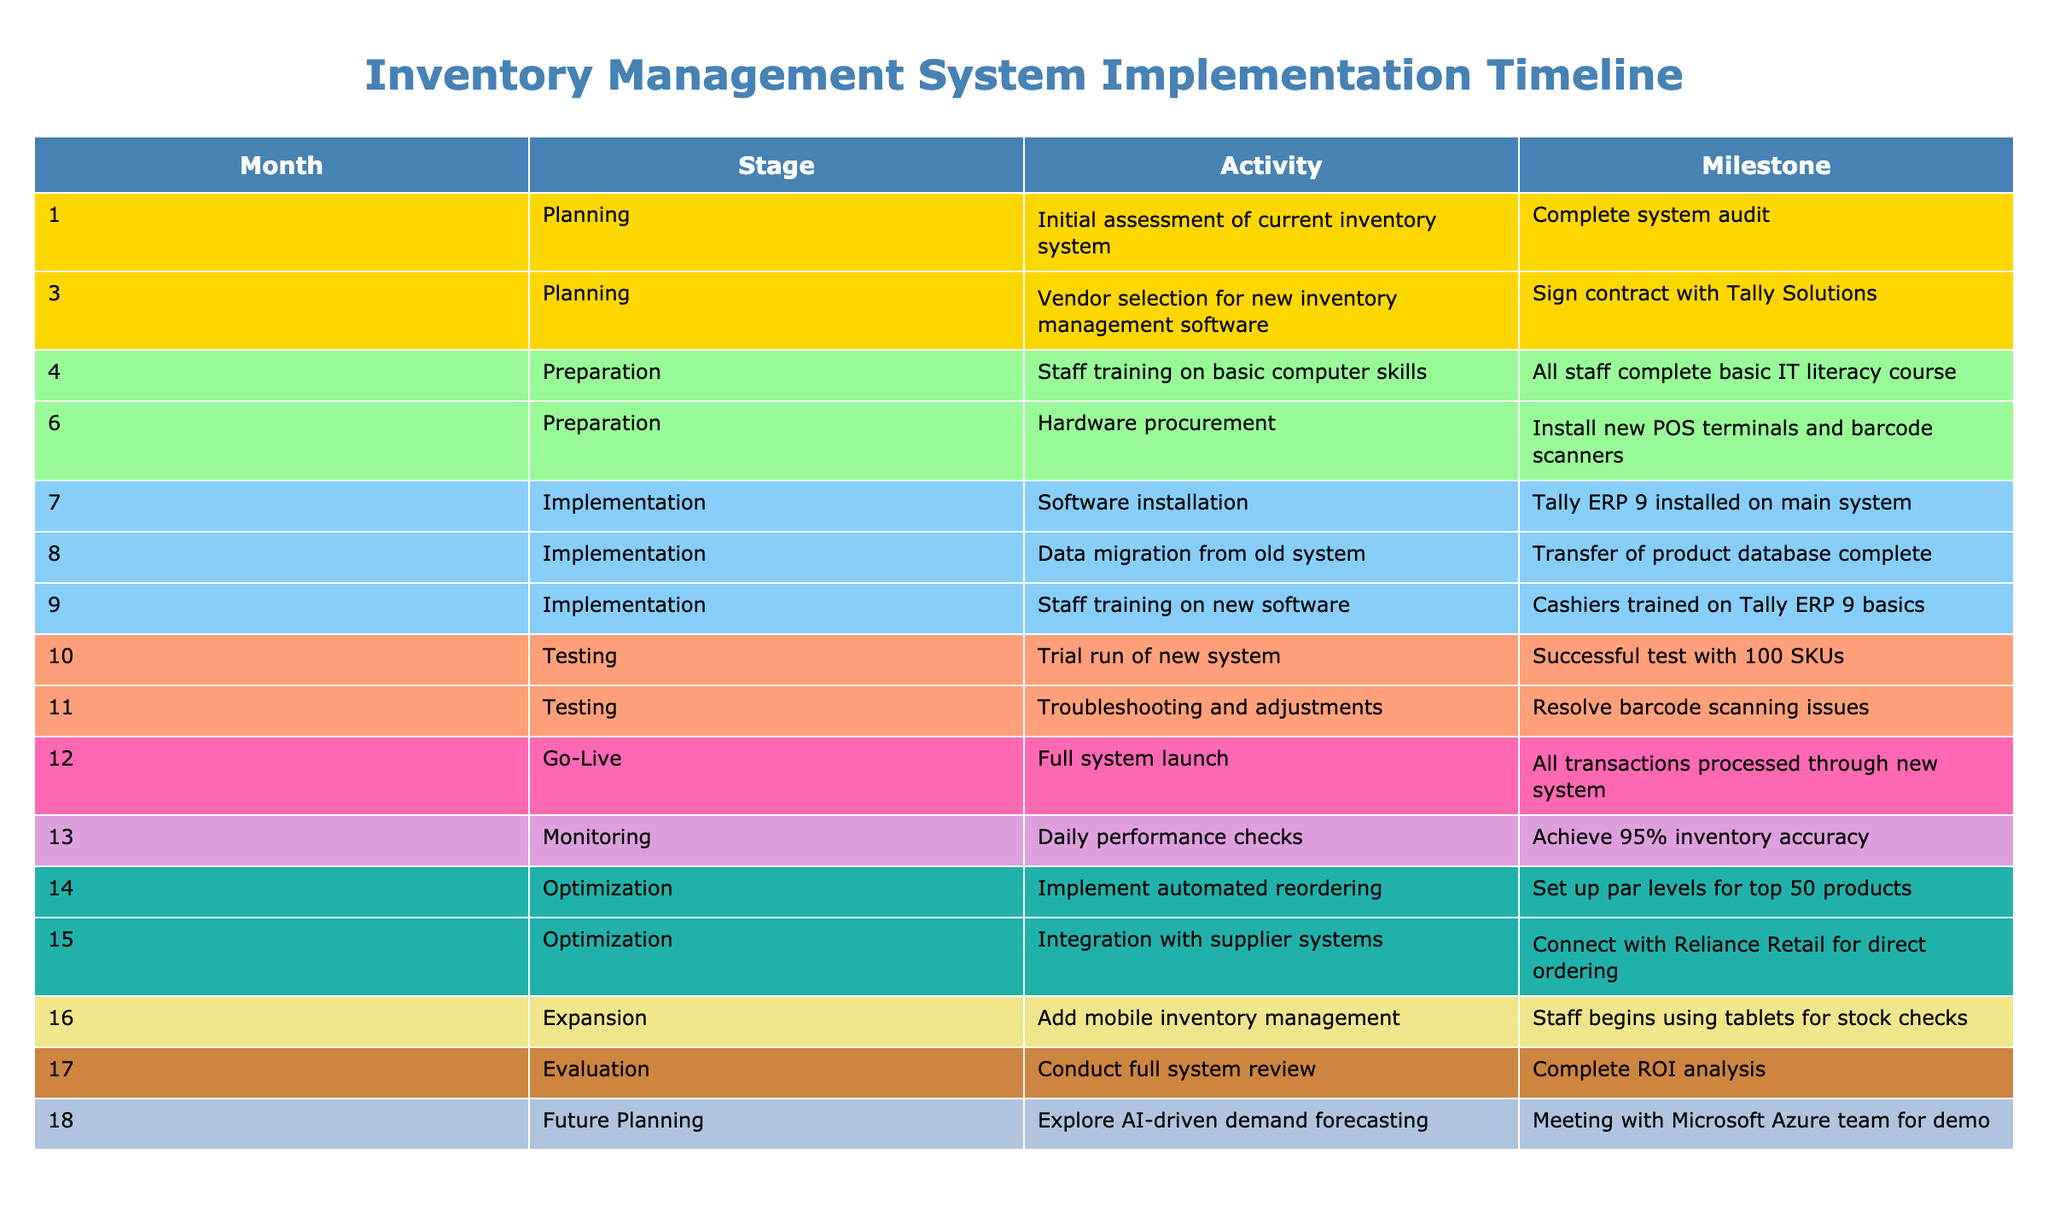What activity was conducted in month 12? Referring to the table, month 12 corresponds to the "Go-Live" stage, and the activity listed is "Full system launch."
Answer: Full system launch Which stage comes after the "Testing" stage according to the timeline? The sequence of stages in the timeline shows that the "Testing" stage is followed by the "Go-Live" stage.
Answer: Go-Live How many months were dedicated to the "Preparation" stage? The "Preparation" stage occurs in months 4 and 6. Therefore, there are two months dedicated to this stage.
Answer: 2 Was there any staff training conducted for the new inventory management software? Yes, the table indicates that training was conducted in month 9 for cashiers on Tally ERP 9 basics, confirming that staff training took place.
Answer: Yes What is the main milestone achieved in month 14? In month 14, the activity listed is "Implement automated reordering," and the milestone achieved is "Set up par levels for top 50 products."
Answer: Set up par levels for top 50 products What percentage of inventory accuracy was achieved during the daily performance checks in month 13? The milestone for month 13 indicates that 95% inventory accuracy was achieved during daily performance checks.
Answer: 95% What are the two activities conducted in months 8 and 9? Month 8 involved the activity "Data migration from old system," while month 9's activity was "Staff training on new software."
Answer: Data migration and Staff training In which month was the hardware procured? According to the timeline, the hardware procurement took place in month 6.
Answer: Month 6 How many total stages are represented in the timeline? The table lists nine unique stages throughout the 18-month timeline, which includes: Planning, Preparation, Implementation, Testing, Go-Live, Monitoring, Optimization, Expansion, Evaluation, and Future Planning.
Answer: 9 